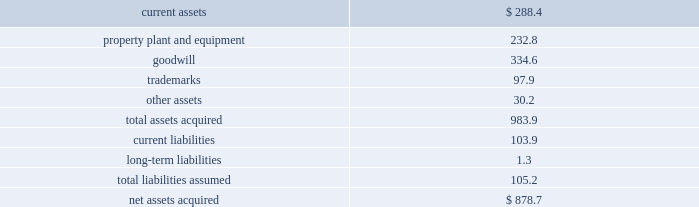492010 annual report consolidation 2013 effective february 28 , 2010 , the company adopted the fasb amended guidance for con- solidation .
This guidance clarifies that the scope of the decrease in ownership provisions applies to the follow- ing : ( i ) a subsidiary or group of assets that is a business or nonprofit activity ; ( ii ) a subsidiary that is a business or nonprofit activity that is transferred to an equity method investee or joint venture ; and ( iii ) an exchange of a group of assets that constitutes a business or nonprofit activ- ity for a noncontrolling interest in an entity ( including an equity method investee or joint venture ) .
This guidance also expands the disclosures about the deconsolidation of a subsidiary or derecognition of a group of assets within the scope of the guidance .
The adoption of this guidance did not have a material impact on the company 2019s consolidated financial statements .
3 . acquisitions : acquisition of bwe 2013 on december 17 , 2007 , the company acquired all of the issued and outstanding capital stock of beam wine estates , inc .
( 201cbwe 201d ) , an indirect wholly-owned subsidiary of fortune brands , inc. , together with bwe 2019s subsidiaries : atlas peak vineyards , inc. , buena vista winery , inc. , clos du bois , inc. , gary farrell wines , inc .
And peak wines international , inc .
( the 201cbwe acquisition 201d ) .
As a result of the bwe acquisition , the company acquired the u.s .
Wine portfolio of fortune brands , inc. , including certain wineries , vineyards or inter- ests therein in the state of california , as well as various super-premium and fine california wine brands including clos du bois and wild horse .
The bwe acquisition sup- ports the company 2019s strategy of strengthening its portfolio with fast-growing super-premium and above wines .
The bwe acquisition strengthens the company 2019s position as the leading wine company in the world and the leading premium wine company in the u.s .
Total consideration paid in cash was $ 877.3 million .
In addition , the company incurred direct acquisition costs of $ 1.4 million .
The purchase price was financed with the net proceeds from the company 2019s december 2007 senior notes ( as defined in note 11 ) and revolver borrowings under the company 2019s june 2006 credit agreement , as amended in february 2007 and november 2007 ( as defined in note 11 ) .
In accordance with the purchase method of accounting , the acquired net assets are recorded at fair value at the date of acquisition .
The purchase price was based primarily on the estimated future operating results of the bwe business , including the factors described above .
In june 2008 , the company sold certain businesses consisting of several of the california wineries and wine brands acquired in the bwe acquisition , as well as certain wineries and wine brands from the states of washington and idaho ( collectively , the 201cpacific northwest business 201d ) ( see note 7 ) .
The results of operations of the bwe business are reported in the constellation wines segment and are included in the consolidated results of operations of the company from the date of acquisition .
The table summarizes the fair values of the assets acquired and liabilities assumed in the bwe acquisition at the date of acquisition .
( in millions ) current assets $ 288.4 property , plant and equipment 232.8 .
Other assets 30.2 total assets acquired 983.9 current liabilities 103.9 long-term liabilities 1.3 total liabilities assumed 105.2 net assets acquired $ 878.7 the trademarks are not subject to amortization .
All of the goodwill is expected to be deductible for tax purposes .
Acquisition of svedka 2013 on march 19 , 2007 , the company acquired the svedka vodka brand ( 201csvedka 201d ) in connection with the acquisition of spirits marque one llc and related business ( the 201csvedka acquisition 201d ) .
Svedka is a premium swedish vodka .
At the time of the acquisition , the svedka acquisition supported the company 2019s strategy of expanding the company 2019s premium spirits business and provided a foundation from which the company looked to leverage its existing and future premium spirits portfolio for growth .
In addition , svedka complemented the company 2019s then existing portfolio of super-premium and value vodka brands by adding a premium vodka brand .
Total consideration paid in cash for the svedka acquisition was $ 385.8 million .
In addition , the company incurred direct acquisition costs of $ 1.3 million .
The pur- chase price was financed with revolver borrowings under the company 2019s june 2006 credit agreement , as amended in february 2007 .
In accordance with the purchase method of accounting , the acquired net assets are recorded at fair value at the date of acquisition .
The purchase price was based primarily on the estimated future operating results of the svedka business , including the factors described above .
The results of operations of the svedka business are reported in the constellation wines segment and are included in the consolidated results of operations of the company from the date of acquisition. .
Did the bwe acquisition cost more than the svedka acquisition? 
Computations: (877.3 > 385.8)
Answer: yes. 